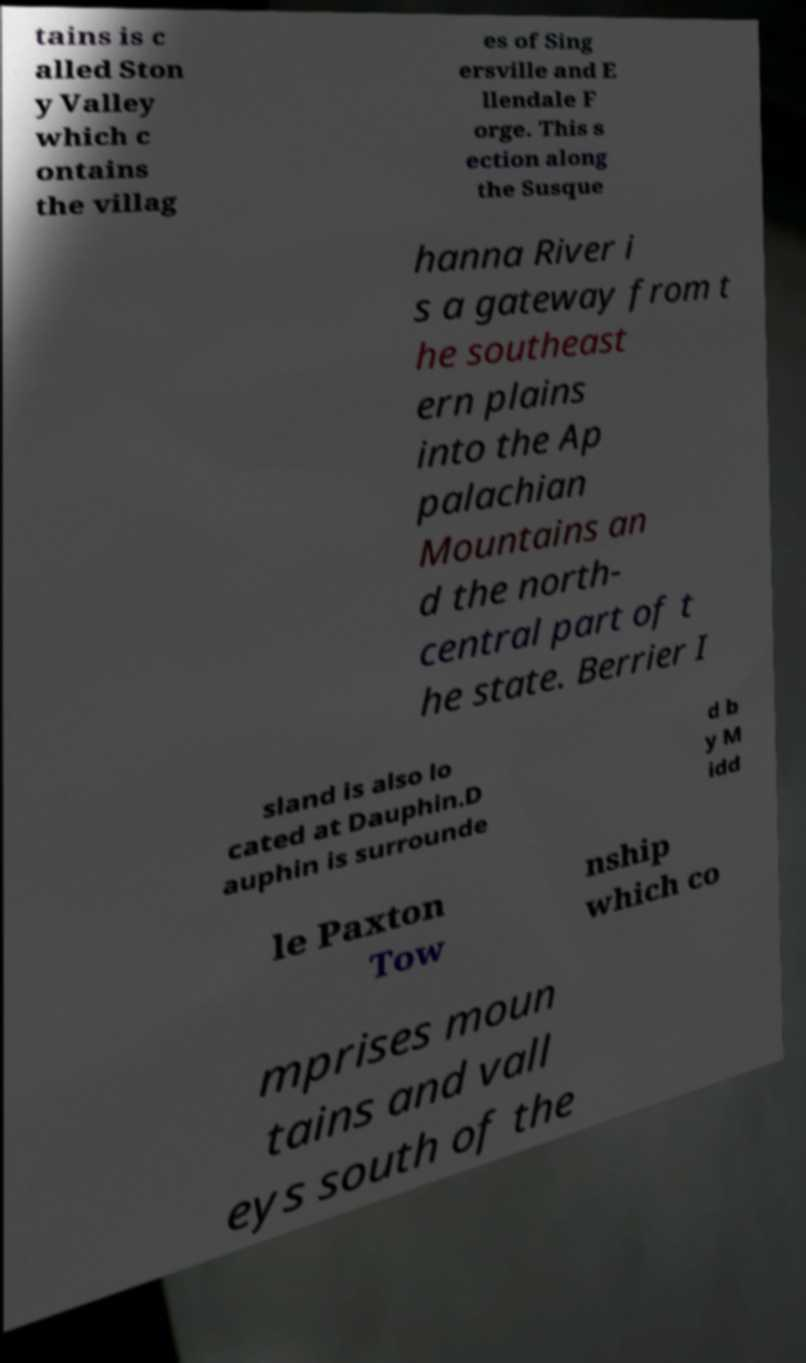Can you read and provide the text displayed in the image?This photo seems to have some interesting text. Can you extract and type it out for me? tains is c alled Ston y Valley which c ontains the villag es of Sing ersville and E llendale F orge. This s ection along the Susque hanna River i s a gateway from t he southeast ern plains into the Ap palachian Mountains an d the north- central part of t he state. Berrier I sland is also lo cated at Dauphin.D auphin is surrounde d b y M idd le Paxton Tow nship which co mprises moun tains and vall eys south of the 